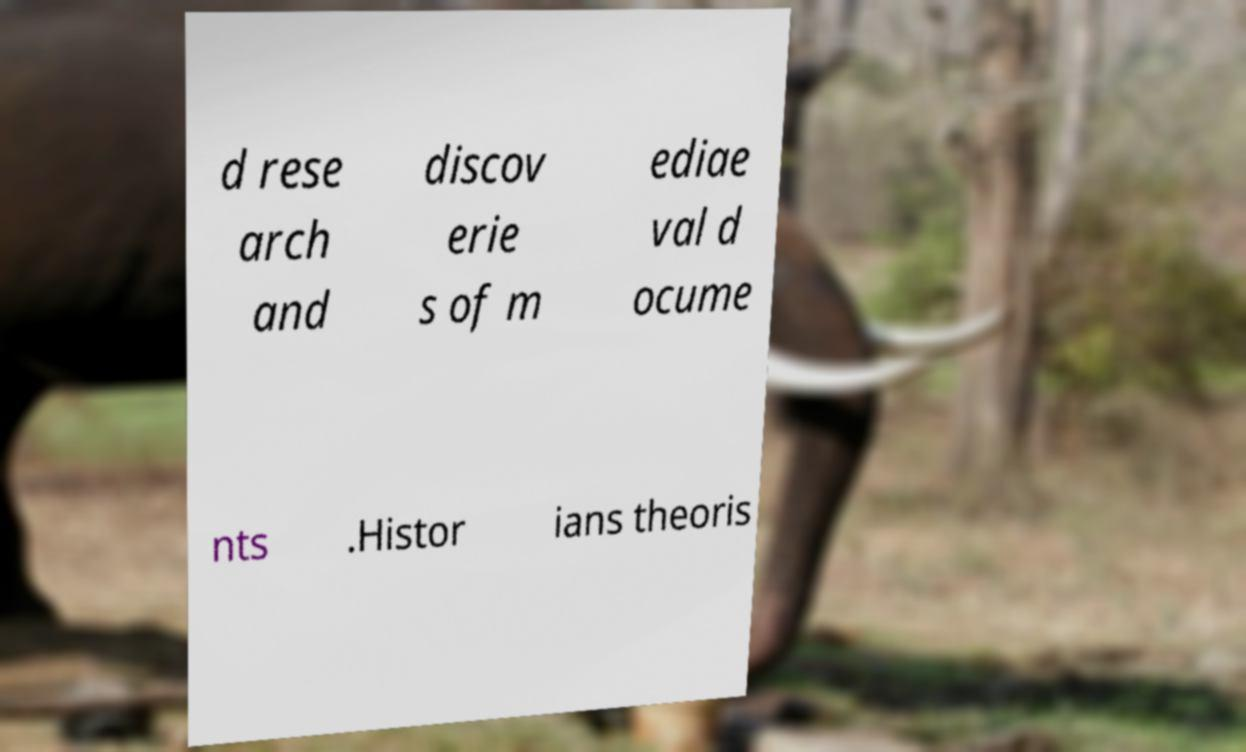Please read and relay the text visible in this image. What does it say? d rese arch and discov erie s of m ediae val d ocume nts .Histor ians theoris 